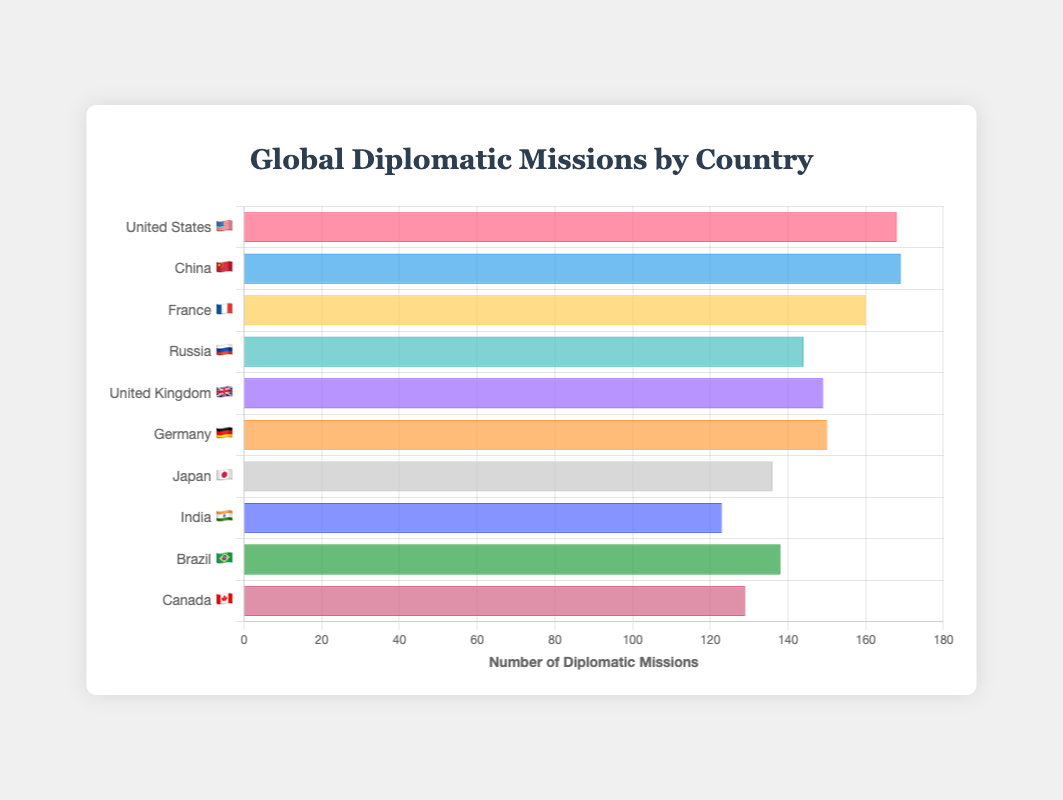What's the total number of diplomatic missions represented in the chart? Add the number of diplomatic missions for all countries: 168 (USA) + 169 (China) + 160 (France) + 144 (Russia) + 149 (UK) + 150 (Germany) + 136 (Japan) + 123 (India) + 138 (Brazil) + 129 (Canada) = 1466
Answer: 1466 Which country has the largest number of diplomatic missions? Look at the bar with the highest value on the chart. China 🇨🇳 has 169 diplomatic missions, which is the largest number.
Answer: China 🇨🇳 How many more diplomatic missions does the United States 🇺🇸 have compared to India 🇮🇳? Subtract India's diplomatic missions from that of the United States: 168 (USA) - 123 (India) = 45
Answer: 45 Which countries have more diplomatic missions: Germany 🇩🇪 or Japan 🇯🇵? Compare the diplomatic missions for Germany and Japan. Germany has 150, while Japan has 136. Therefore, Germany has more.
Answer: Germany 🇩🇪 What's the average number of diplomatic missions for the countries listed? Sum the diplomatic missions for all countries and divide by the number of countries: 1466 (total missions) / 10 (countries) = 146.6
Answer: 146.6 Order the countries by their number of diplomatic missions from highest to lowest. List the countries by descending order of their diplomatic missions: China 🇨🇳 (169), United States 🇺🇸 (168), France 🇫🇷 (160), Germany 🇩🇪 (150), United Kingdom 🇬🇧 (149), Russia 🇷🇺 (144), Brazil 🇧🇷 (138), Japan 🇯🇵 (136), Canada 🇨🇦 (129), India 🇮🇳 (123)
Answer: China 🇨🇳, United States 🇺🇸, France 🇫🇷, Germany 🇩🇪, United Kingdom 🇬🇧, Russia 🇷🇺, Brazil 🇧🇷, Japan 🇯🇵, Canada 🇨🇦, India 🇮🇳 Among the countries with more than 140 diplomatic missions, which one has the fewest? Identify countries with more than 140 diplomatic missions and compare. Russia 🇷🇺 has 144 missions, which is the fewest among those over 140 missions.
Answer: Russia 🇷🇺 What is the median number of diplomatic missions for the countries in the chart? Order the countries by number of missions and find the middle values: 123 (India), 129 (Canada), 136 (Japan), 138 (Brazil), 144 (Russia), 149 (UK), 150 (Germany), 160 (France), 168 (USA), 169 (China). The median is the average of the middle two values: (144 + 149) / 2 = 146.5
Answer: 146.5 Are there more countries with fewer than 140 diplomatic missions or with more than 140? Count the number of countries with fewer than 140: Japan (136), India (123), Brazil (138), Canada (129) = 4. Count the number with more than 140: USA (168), China (169), France (160), Russia (144), UK (149), Germany (150) = 6. There are more countries with more than 140 missions.
Answer: More countries have more than 140 missions Which country has the closest number of diplomatic missions to the average number? Calculate the average number of diplomatic missions (146.6) and find the country with the closest value: Germany (150) is the closest.
Answer: Germany 🇩🇪 